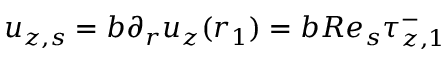<formula> <loc_0><loc_0><loc_500><loc_500>u _ { z , s } = b \partial _ { r } u _ { z } ( r _ { 1 } ) = b R e _ { s } \tau _ { z , 1 } ^ { - }</formula> 